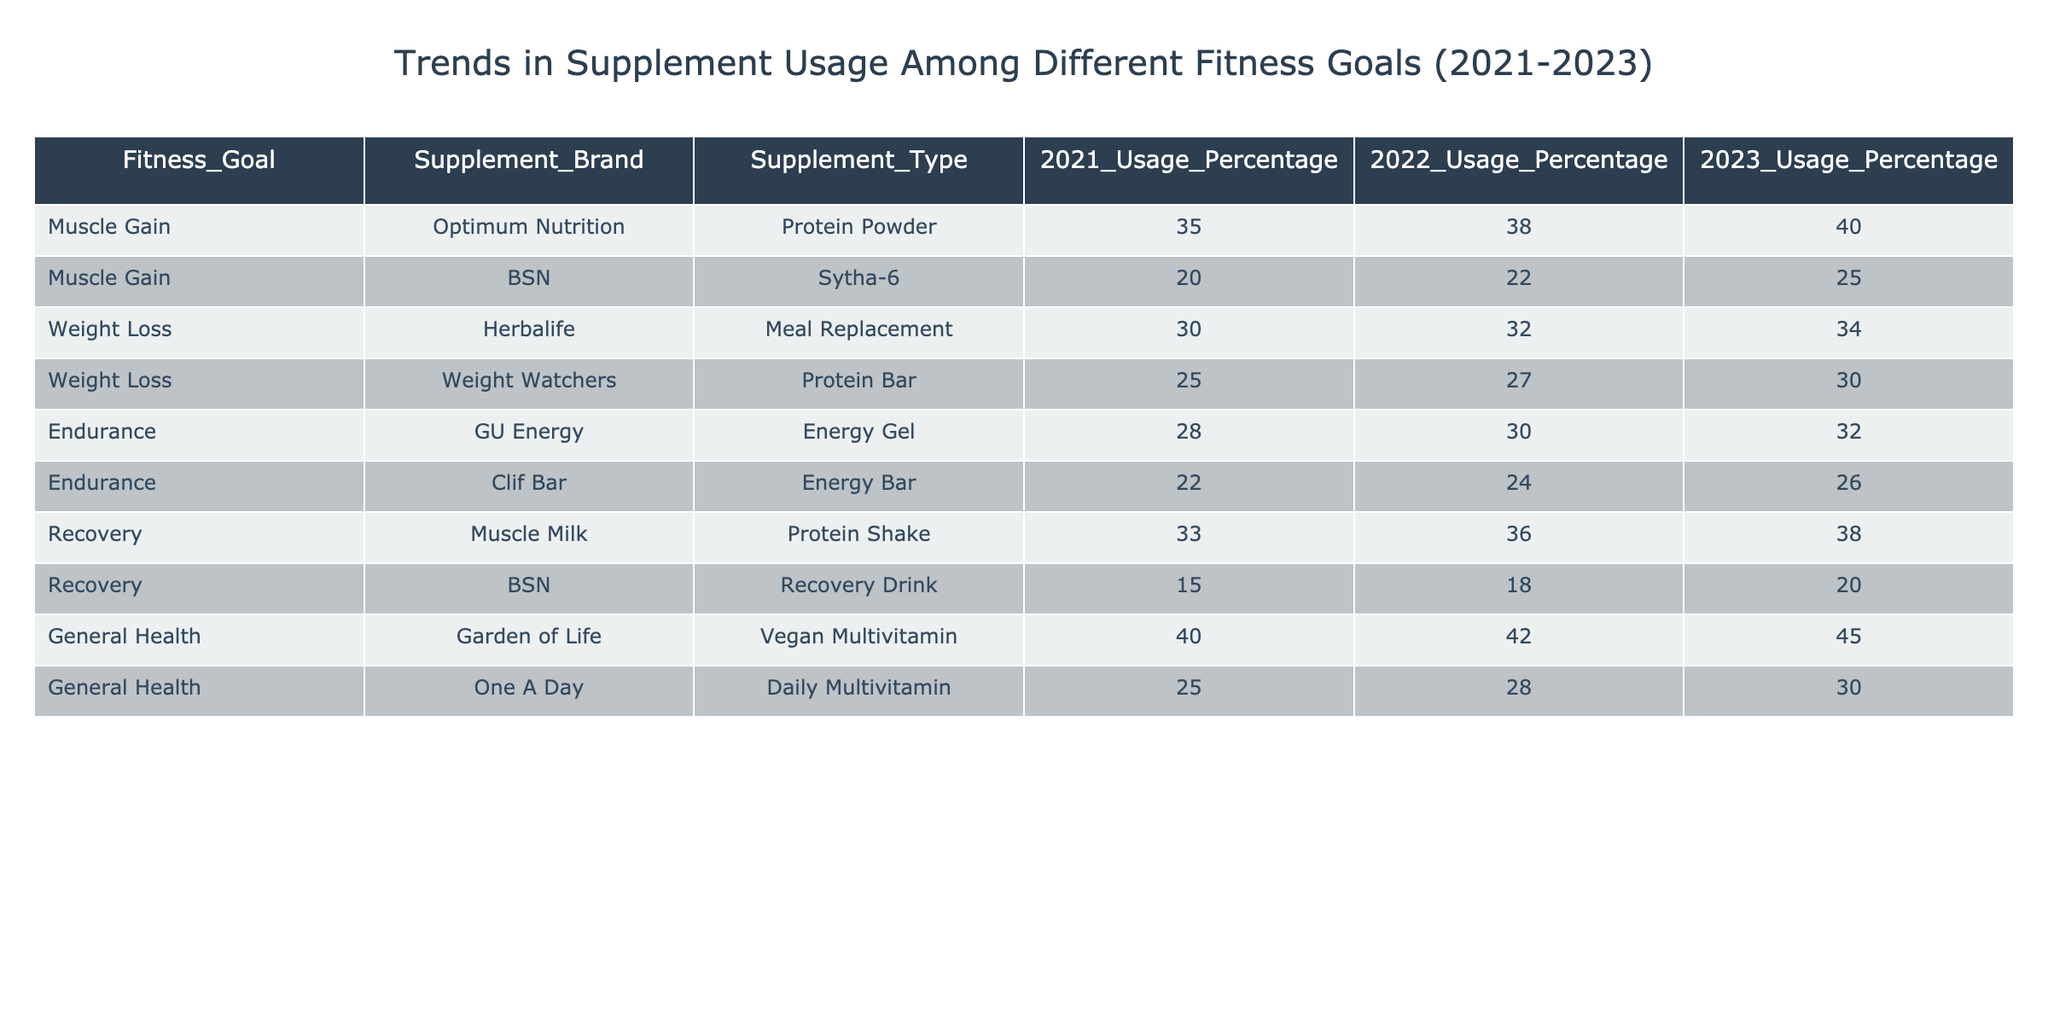What was the usage percentage of Optimum Nutrition protein powder in 2023? According to the table, the usage percentage of Optimum Nutrition protein powder in 2023 is clearly listed as 40%.
Answer: 40% Which supplement brand had the highest percentage usage for weight loss in 2022? In the table, for weight loss in 2022, Herbalife's Meal Replacement is at 32%, while Weight Watchers' Protein Bar is at 27%. Therefore, Herbalife had the highest usage percentage.
Answer: Herbalife What is the overall trend in supplement usage for muscle gain from 2021 to 2023? The table shows that both Optimum Nutrition and BSN's usage percentages have increased from 35% to 40% and 20% to 25%, respectively. Overall, this indicates a positive trend in supplement usage for muscle gain.
Answer: Positive trend Is there a recovery drink that saw a decrease in usage from 2021 to 2023? According to the table, both recovery supplements, Muscle Milk and BSN Recovery Drink, have shown an increase in usage percentages from 33% to 38% and 15% to 20%, respectively. Therefore, there was no decrease.
Answer: No What is the average percentage usage for the general health supplements across the three years? The average is calculated by summing the usage percentages for Garden of Life and One A Day across 2021, 2022, and 2023, which is (40 + 42 + 45 + 25 + 28 + 30) / 6 = 33.75. Thus, the average usage percentage for general health supplements is approximately 33.75%.
Answer: 33.75% How much more popular was the GU Energy gel compared to the Clif Bar for endurance in 2023? The table shows that GU Energy gel has a percentage of 32% for 2023, while Clif Bar has 26%. To find the difference, subtract the two values: 32 - 26 = 6. Therefore, GU Energy gel was 6% more popular.
Answer: 6% What is the percentage increase in Herbalife Meal Replacement usage from 2021 to 2023? The usage percentage in 2021 was 30%, and in 2023, it is 34%. The increase is calculated as (34 - 30) = 4. To find the percentage increase, we compute (4/30) * 100 = 13.33%. Thus, Herbalife's usage saw a 13.33% increase from 2021 to 2023.
Answer: 13.33% Did the One A Day multivitamin have the same usage percentage in any two years? By examining the table, we see that the usage percentages for One A Day were 25% in 2021, 28% in 2022, and 30% in 2023. None of these percentages are the same, confirming that it did not have the same usage percentage in any two years.
Answer: No 